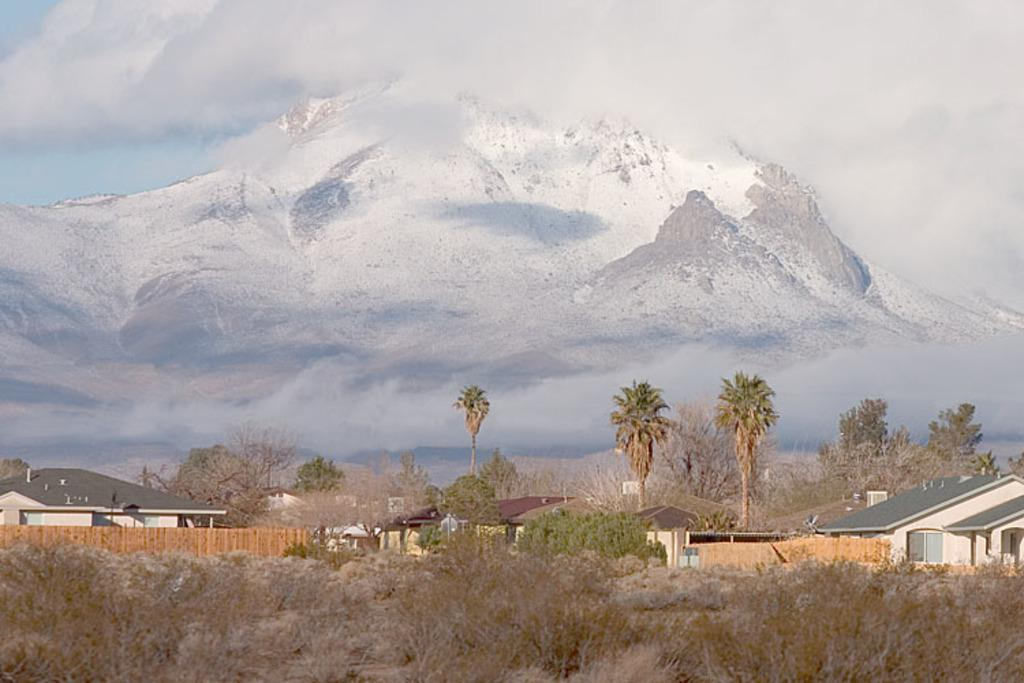What type of structures can be seen in the image? There are houses in the image. What type of vegetation is present in the image? There are trees and grass in the image. What is the weather like in the image? There is snow in the image, indicating a cold or wintery environment. What type of natural feature can be seen in the image? There is a rock in the image. Where is the grandmother sitting in the image? There is no grandmother present in the image. What type of wave can be seen in the image? There are no waves present in the image; it features houses, trees, grass, snow, and a rock. 